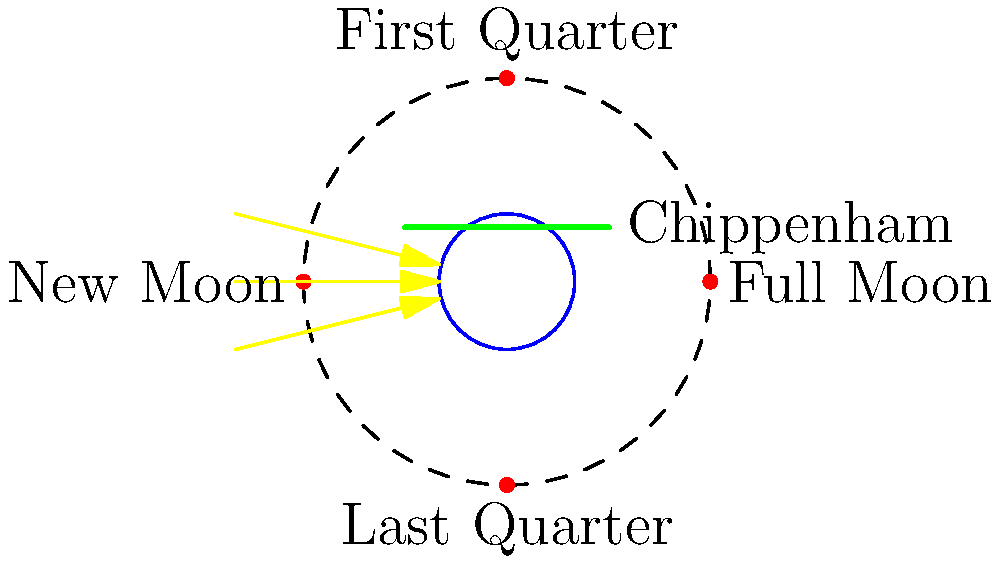As you gaze at the night sky from your shop in Chippenham, how does the appearance of the First Quarter Moon differ from what might be seen at the equator? To understand how the First Quarter Moon appears from Chippenham compared to the equator, we need to consider the following steps:

1. Chippenham's latitude: Chippenham is located at approximately 51.5°N latitude.

2. Moon's position during First Quarter:
   - The First Quarter Moon is 90° away from the Sun in its orbit.
   - It appears as a half-illuminated disc in the sky.

3. Effect of latitude on moon's appearance:
   - At the equator (0° latitude), the First Quarter Moon appears as a vertical half-circle, with the right half illuminated.
   - As you move north, the illuminated half appears to rotate clockwise.

4. Chippenham's view:
   - At 51.5°N, the First Quarter Moon will appear tilted.
   - The illuminated half will be rotated approximately 51.5° clockwise from the vertical position seen at the equator.

5. Seasonal variations:
   - The exact tilt can vary slightly throughout the year due to the Moon's orbital inclination and the Earth's axial tilt.
   - However, the general clockwise rotation effect remains consistent.

6. Time of moonrise and moonset:
   - In Chippenham, the First Quarter Moon will typically rise around noon and set around midnight.
   - This timing is similar at all latitudes, but the path across the sky differs.

The key difference is that from Chippenham, the First Quarter Moon will appear as a tilted half-circle, with the illuminated portion rotated clockwise compared to the vertical split seen at the equator.
Answer: Tilted half-circle, rotated ~51.5° clockwise from vertical 